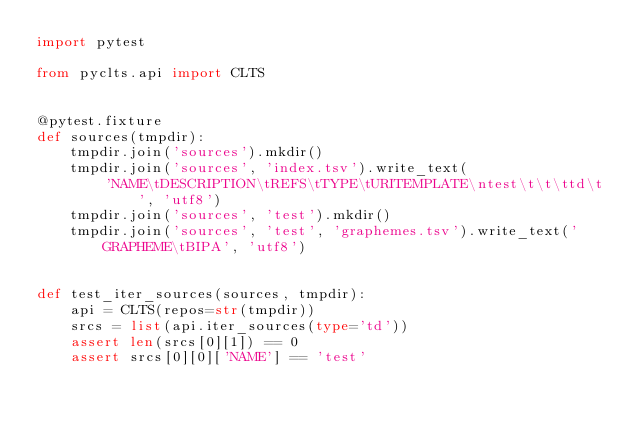Convert code to text. <code><loc_0><loc_0><loc_500><loc_500><_Python_>import pytest

from pyclts.api import CLTS


@pytest.fixture
def sources(tmpdir):
    tmpdir.join('sources').mkdir()
    tmpdir.join('sources', 'index.tsv').write_text(
        'NAME\tDESCRIPTION\tREFS\tTYPE\tURITEMPLATE\ntest\t\t\ttd\t', 'utf8')
    tmpdir.join('sources', 'test').mkdir()
    tmpdir.join('sources', 'test', 'graphemes.tsv').write_text('GRAPHEME\tBIPA', 'utf8')


def test_iter_sources(sources, tmpdir):
    api = CLTS(repos=str(tmpdir))
    srcs = list(api.iter_sources(type='td'))
    assert len(srcs[0][1]) == 0
    assert srcs[0][0]['NAME'] == 'test'
</code> 